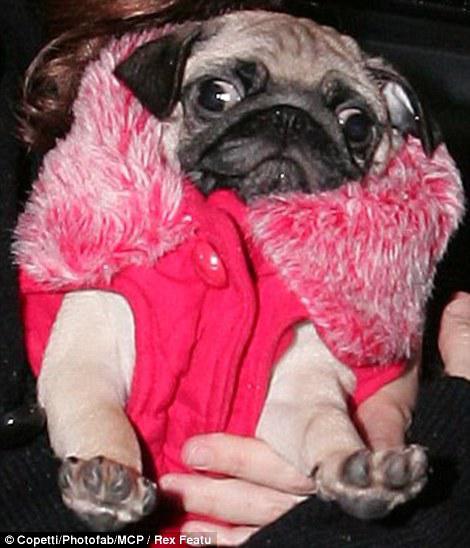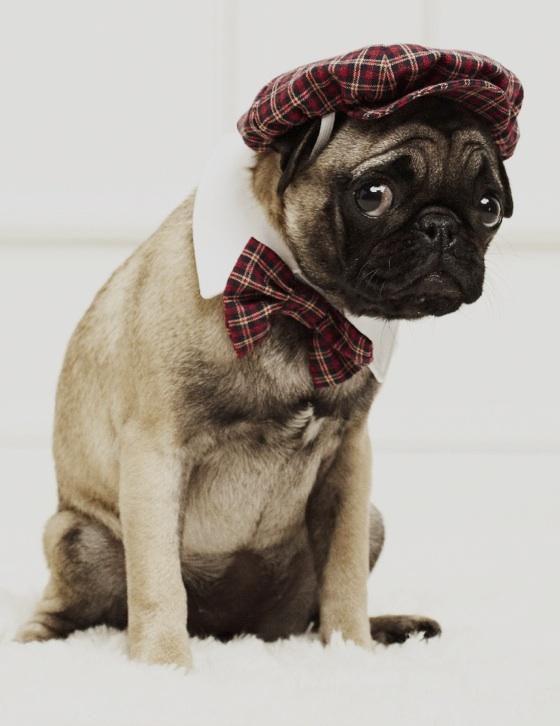The first image is the image on the left, the second image is the image on the right. Considering the images on both sides, is "One image shows a horizontal row of pug dogs that are not in costume." valid? Answer yes or no. No. The first image is the image on the left, the second image is the image on the right. Examine the images to the left and right. Is the description "Both dogs are being dressed in human like attire." accurate? Answer yes or no. Yes. 